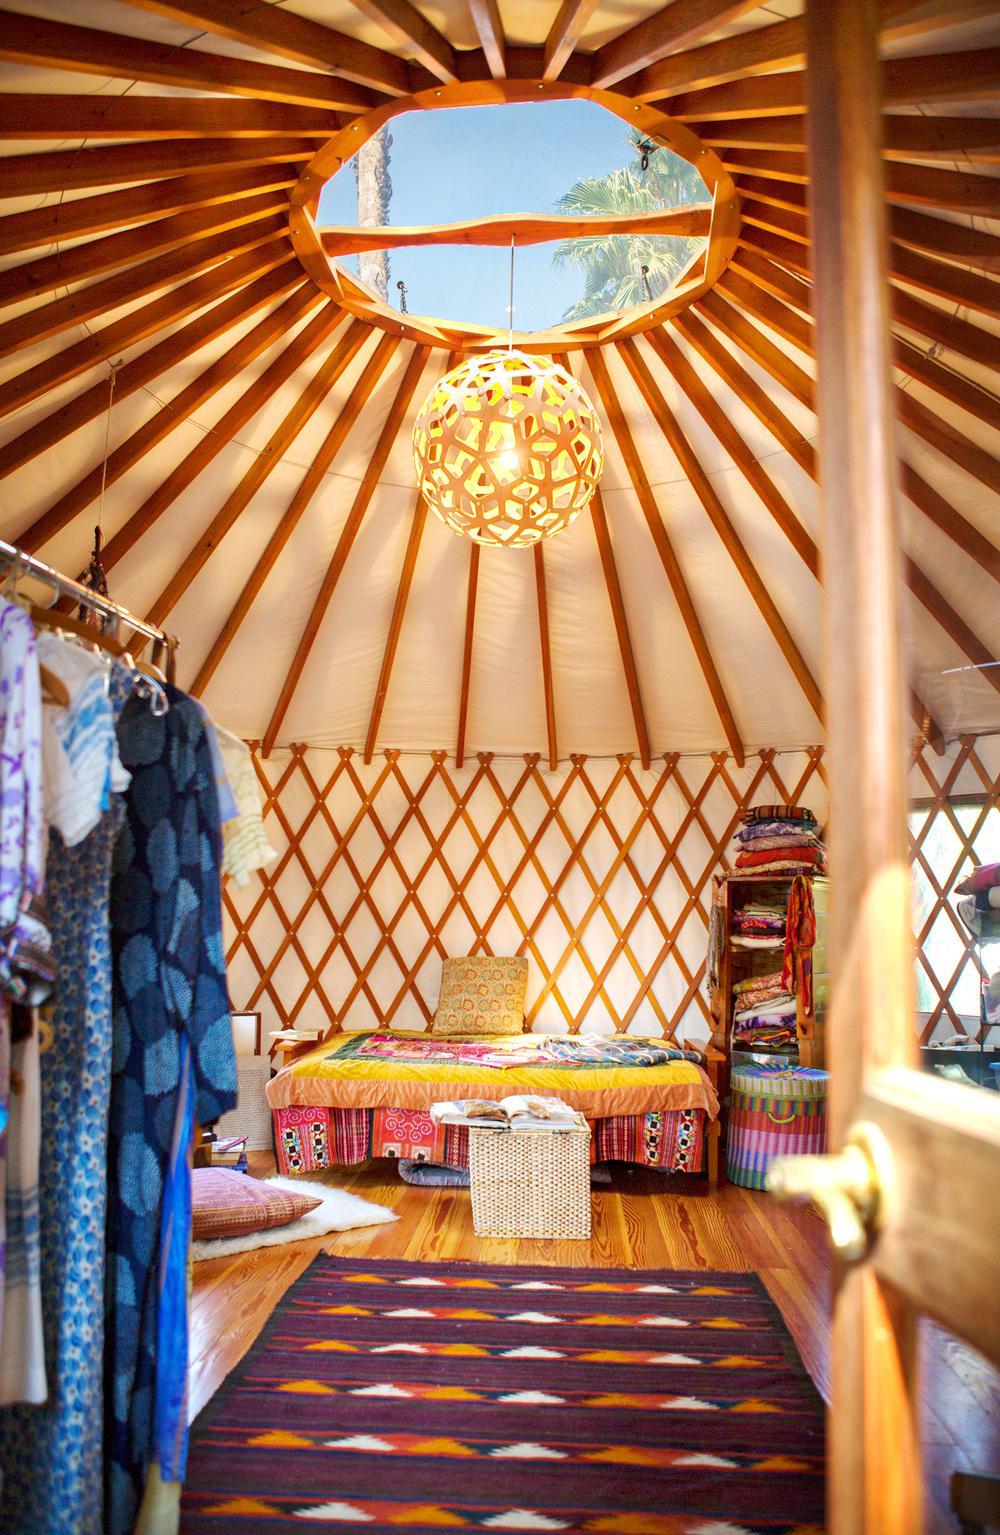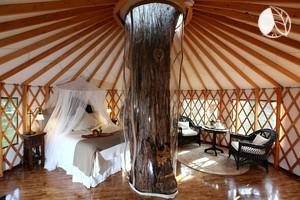The first image is the image on the left, the second image is the image on the right. Analyze the images presented: Is the assertion "An image shows the exterior framework of an unfinished building with a cone-shaped roof." valid? Answer yes or no. No. The first image is the image on the left, the second image is the image on the right. Analyze the images presented: Is the assertion "One of the images is showing the hut from the outside." valid? Answer yes or no. No. 